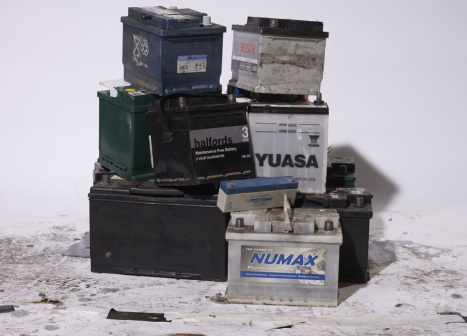Imagine the batteries in this image are sentient beings living together. Describe a day in their life. In the bustling world of Sentient Battery Town, every day is filled with activity. NUMAX, the oldest and wisest battery, often regales younger batteries with tales of his lengthy service powering a powerful truck. YUASA and Halfords 3, notable for their vibrant colors, spend their days reminiscing about their adventures in different vehicles. Despite their worn-out appearances, they band together to keep the environment around them clean, knowing their responsibility towards the earth. In the evenings, they huddle together, glowing faintly as they share stories under the starry sky, ever hopeful for a new lease on life through recycling. What would happen if one of the batteries was chosen to be recycled? If a battery were chosen to be recycled, it would be a day of mixed emotions for the battery community. While there would be sadness from losing a friend, there would also be joy and celebration, knowing that the chosen battery would get a second chance at life. The battery would say heartfelt goodbyes, and other batteries would share memories and gifts for the journey. The recycled battery would dream of becoming a part of a new, eco-friendly car, looking forward to adventures and supporting a sustainable future. 